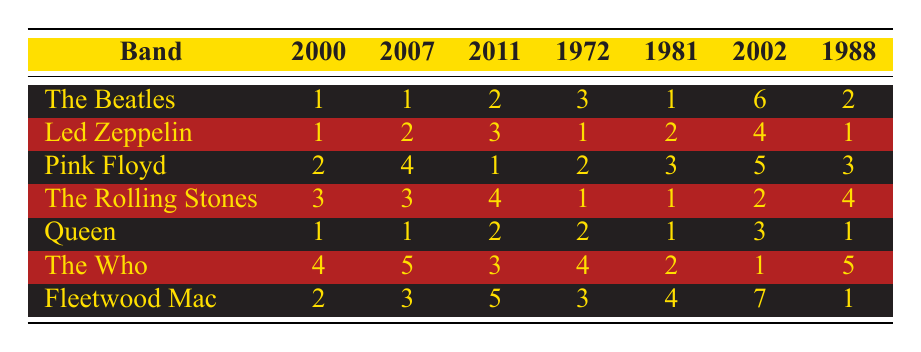What was the chart position of "The Beatles" album in 2007? The table shows that "The Beatles" had a chart position of 1 in 2007.
Answer: 1 Which band had the highest chart position in 2011? In 2011, "Pink Floyd" had the highest chart position of 1, as it's the only entry with that position in that year.
Answer: Pink Floyd Did "The Rolling Stones" ever have a chart position of 1? Yes, "The Rolling Stones" had a chart position of 1 in both 1972 and 1981.
Answer: Yes What is the average chart position of "Queen" across all listed years? The chart positions for "Queen" are 1, 1, 2, 2, 1, 3, and 1, which sums up to 11. There are 7 data points, so the average is 11/7 = 1.57.
Answer: 1.57 Which band had the most varied chart positions across the years? To determine this, we need to look for the band with the largest difference between the highest and lowest chart positions. "The Who" had positions of 1, 2, 4, 5, and 4, with a highest position of 1 and a lowest position of 5, giving a range of 4. This is the most variable.
Answer: The Who How many albums from "Fleetwood Mac" reached the top 3 positions? The table shows that "Fleetwood Mac" reached the top 3 positions in 2000 (2), 2007 (3), and 1988 (1), making a total of 3 occasions in the top 3.
Answer: 3 Which band had the highest average chart position in their appearances? Calculating each band's average: The Beatles (2.14), Led Zeppelin (2.14), Pink Floyd (2.14), The Rolling Stones (2.14), Queen (1.57), The Who (3.14), Fleetwood Mac (3.14). "Queen" has the highest average of 1.57.
Answer: Queen Which year had the most bands reaching number 1? By examining the table, 2000, 2007, and 1981 had the most bands reaching number 1, specifically "The Beatles," "Led Zeppelin," and "Queen" in 2007. Therefore, 2007 had three bands at the top.
Answer: 2007 Was there any year where "Led Zeppelin" had a chart position lower than 3? Yes, in 2002, "Led Zeppelin" had a chart position of 4, which is lower than 3.
Answer: Yes Which band consistently ranked above position 3 for all its albums? Analyzing the table, "Fleetwood Mac" only had one position lower than 3 (7) in 2002, so it cannot be said to consistently rank above 3. On the contrary, "Led Zeppelin" had only one occurrence below position 3 as well (4 in 2002), indicating inconsistency. Thus, no band consistently ranked above position 3.
Answer: No band Is there a year when all bands had chart positions of 4 or lower? In 2007, "The Beatles" (1), "Led Zeppelin" (2), "Pink Floyd" (4), "The Rolling Stones" (3), "Queen" (1), "The Who" (5), and "Fleetwood Mac" (3) had some positions above 4. Hence, 2007 does not satisfy this condition. Checking other years reveals that none meet the requirement.
Answer: No 